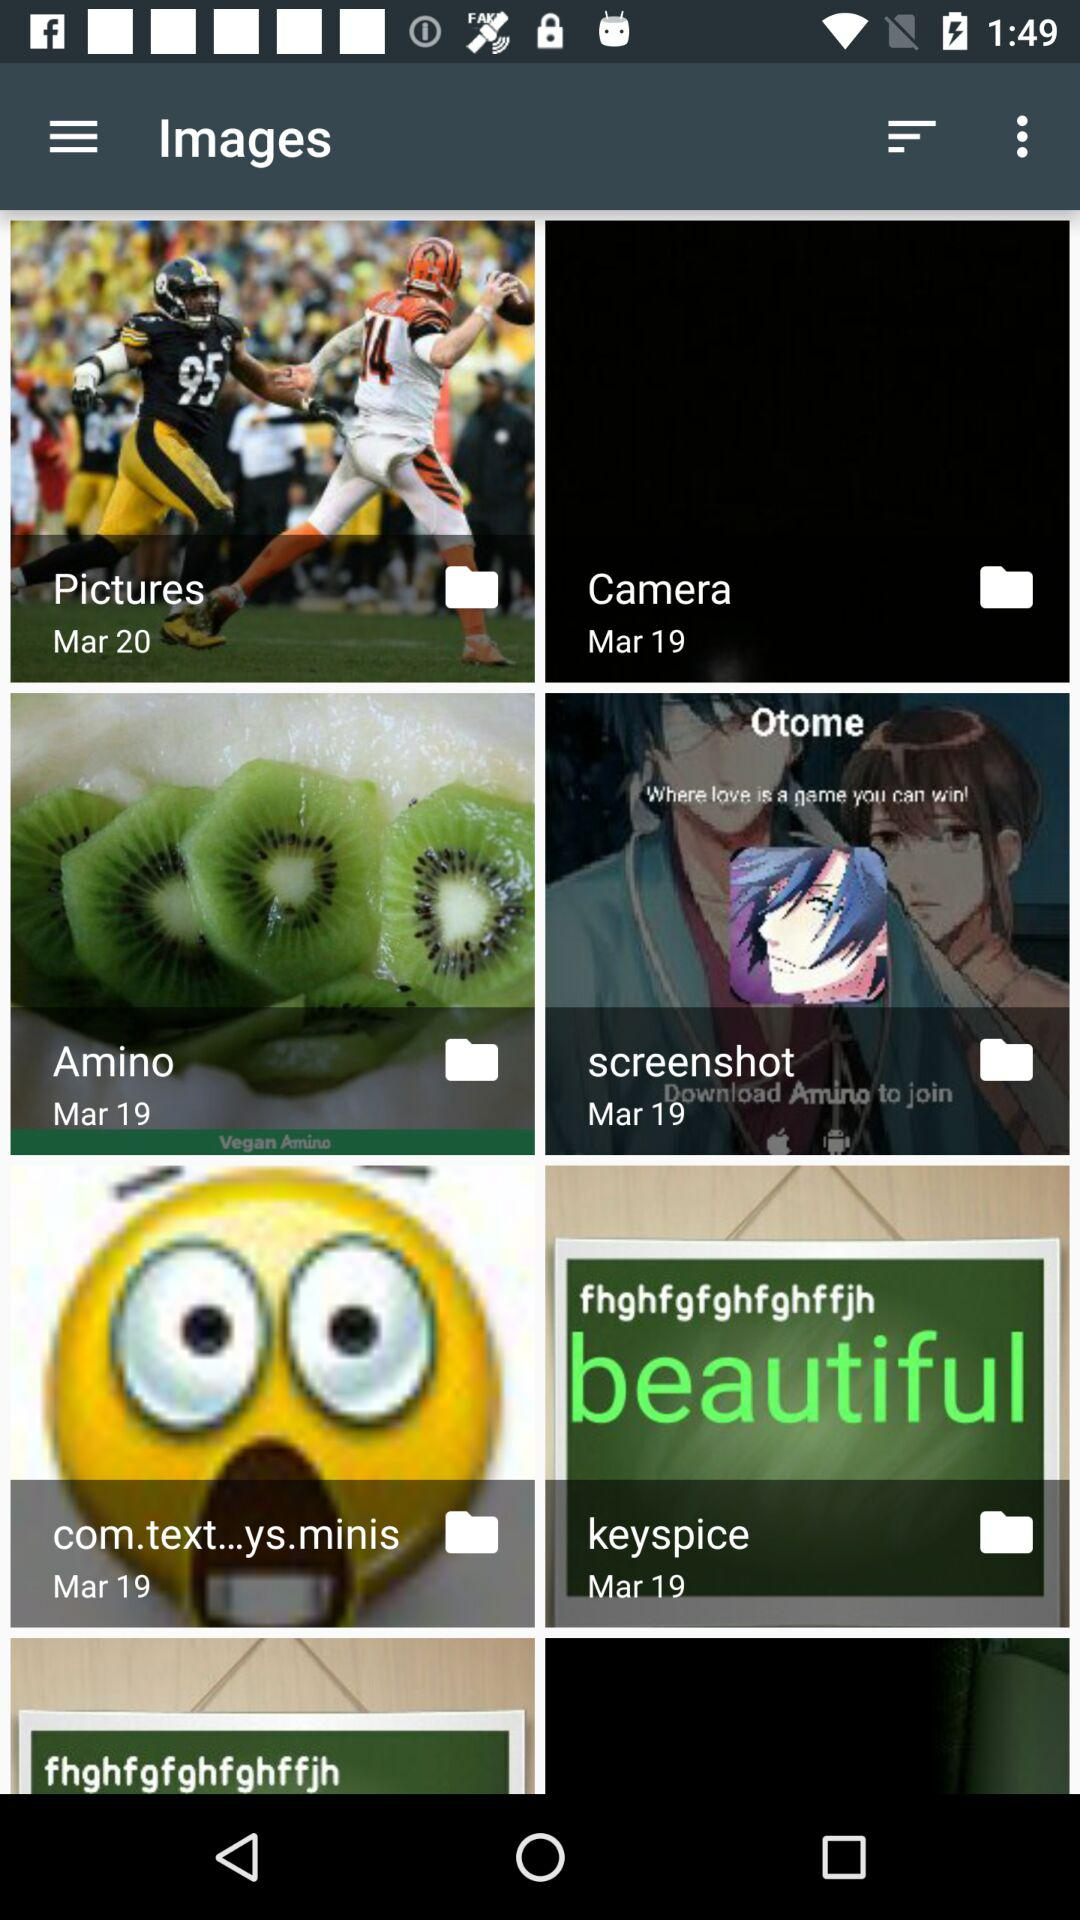What is the date of "Pictures" folder? The date is March 20. 